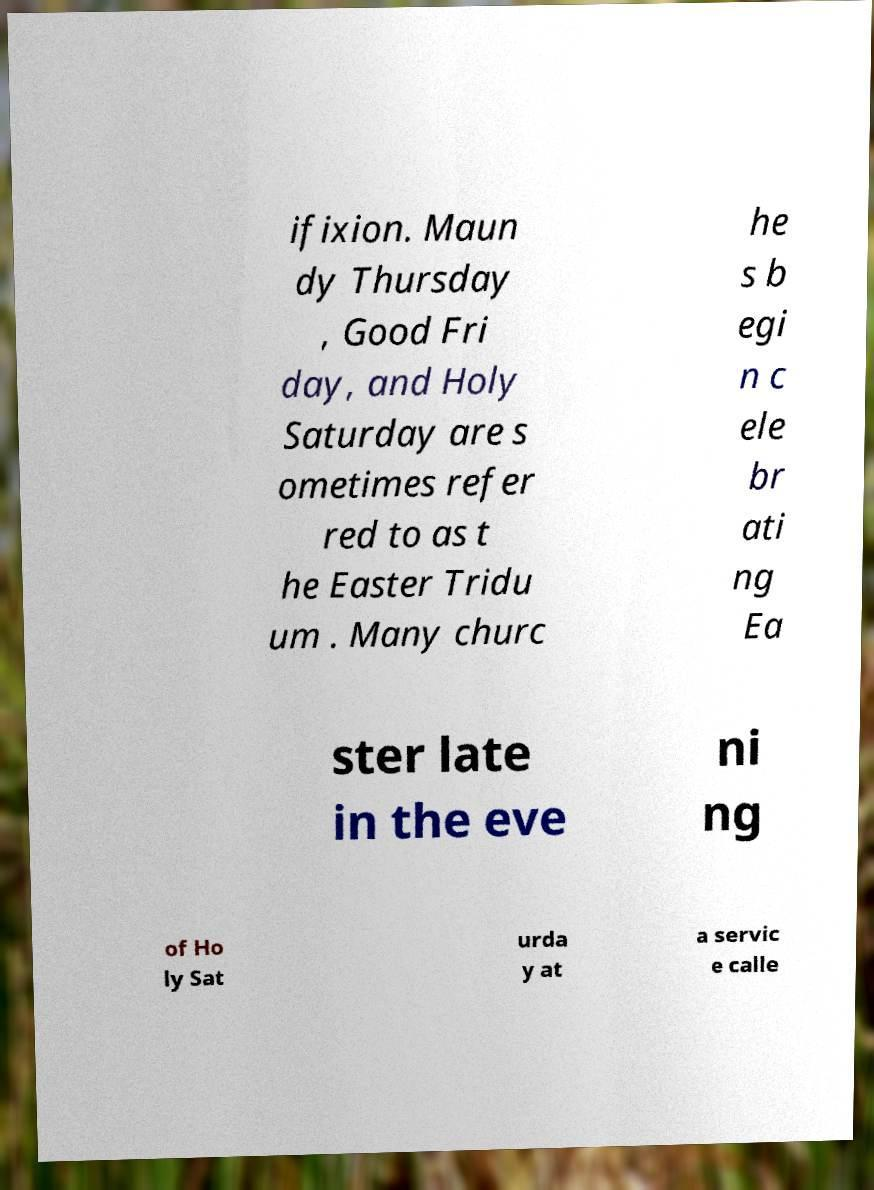Could you assist in decoding the text presented in this image and type it out clearly? ifixion. Maun dy Thursday , Good Fri day, and Holy Saturday are s ometimes refer red to as t he Easter Tridu um . Many churc he s b egi n c ele br ati ng Ea ster late in the eve ni ng of Ho ly Sat urda y at a servic e calle 